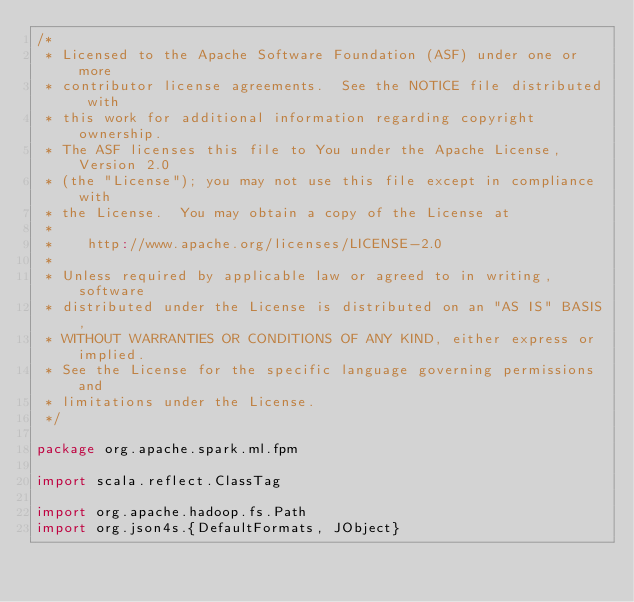<code> <loc_0><loc_0><loc_500><loc_500><_Scala_>/*
 * Licensed to the Apache Software Foundation (ASF) under one or more
 * contributor license agreements.  See the NOTICE file distributed with
 * this work for additional information regarding copyright ownership.
 * The ASF licenses this file to You under the Apache License, Version 2.0
 * (the "License"); you may not use this file except in compliance with
 * the License.  You may obtain a copy of the License at
 *
 *    http://www.apache.org/licenses/LICENSE-2.0
 *
 * Unless required by applicable law or agreed to in writing, software
 * distributed under the License is distributed on an "AS IS" BASIS,
 * WITHOUT WARRANTIES OR CONDITIONS OF ANY KIND, either express or implied.
 * See the License for the specific language governing permissions and
 * limitations under the License.
 */

package org.apache.spark.ml.fpm

import scala.reflect.ClassTag

import org.apache.hadoop.fs.Path
import org.json4s.{DefaultFormats, JObject}</code> 